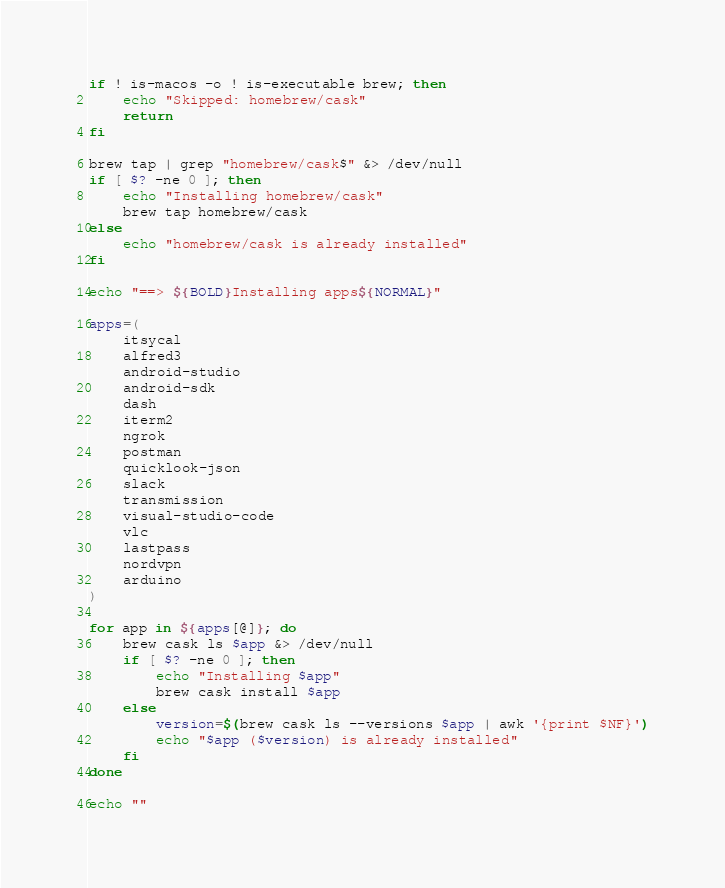Convert code to text. <code><loc_0><loc_0><loc_500><loc_500><_Bash_>if ! is-macos -o ! is-executable brew; then
    echo "Skipped: homebrew/cask"
    return
fi

brew tap | grep "homebrew/cask$" &> /dev/null
if [ $? -ne 0 ]; then
    echo "Installing homebrew/cask"
    brew tap homebrew/cask
else
    echo "homebrew/cask is already installed"
fi

echo "==> ${BOLD}Installing apps${NORMAL}"

apps=(
    itsycal
    alfred3
    android-studio
    android-sdk
    dash
    iterm2
    ngrok
    postman
    quicklook-json
    slack
    transmission
    visual-studio-code
    vlc
    lastpass
    nordvpn
    arduino
)

for app in ${apps[@]}; do
    brew cask ls $app &> /dev/null
    if [ $? -ne 0 ]; then
        echo "Installing $app"
        brew cask install $app
    else
        version=$(brew cask ls --versions $app | awk '{print $NF}')
        echo "$app ($version) is already installed"
    fi
done

echo ""
</code> 